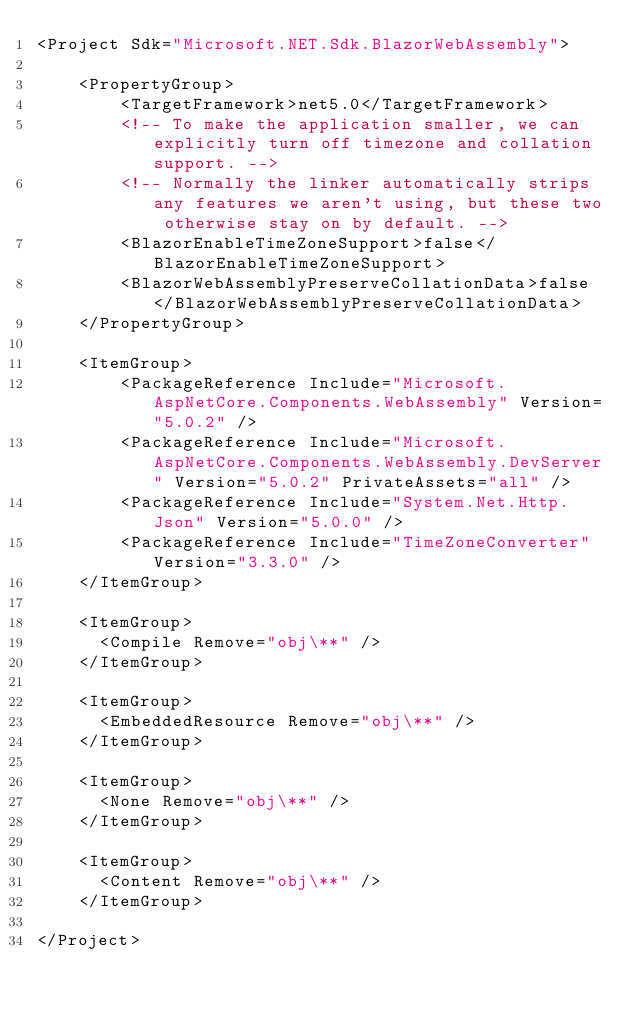Convert code to text. <code><loc_0><loc_0><loc_500><loc_500><_XML_><Project Sdk="Microsoft.NET.Sdk.BlazorWebAssembly">

    <PropertyGroup>
        <TargetFramework>net5.0</TargetFramework>
        <!-- To make the application smaller, we can explicitly turn off timezone and collation support. -->
        <!-- Normally the linker automatically strips any features we aren't using, but these two otherwise stay on by default. -->
        <BlazorEnableTimeZoneSupport>false</BlazorEnableTimeZoneSupport>
        <BlazorWebAssemblyPreserveCollationData>false</BlazorWebAssemblyPreserveCollationData>
    </PropertyGroup>

    <ItemGroup>
        <PackageReference Include="Microsoft.AspNetCore.Components.WebAssembly" Version="5.0.2" />
        <PackageReference Include="Microsoft.AspNetCore.Components.WebAssembly.DevServer" Version="5.0.2" PrivateAssets="all" />
        <PackageReference Include="System.Net.Http.Json" Version="5.0.0" />
        <PackageReference Include="TimeZoneConverter" Version="3.3.0" />
    </ItemGroup>

    <ItemGroup>
      <Compile Remove="obj\**" />
    </ItemGroup>

    <ItemGroup>
      <EmbeddedResource Remove="obj\**" />
    </ItemGroup>

    <ItemGroup>
      <None Remove="obj\**" />
    </ItemGroup>

    <ItemGroup>
      <Content Remove="obj\**" />
    </ItemGroup>

</Project>
</code> 